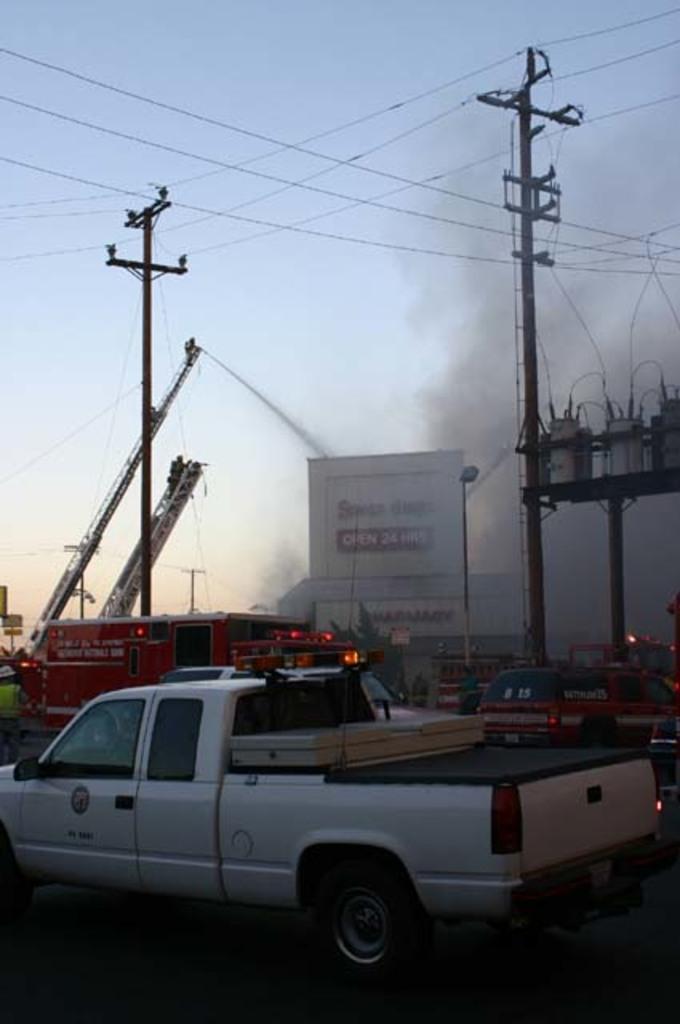Please provide a concise description of this image. In this image there are cars and a fire truck, in front of the fire truck there is a billboard, electric poles with cables on it and transformers with cables, behind the billboard there are buildings and sign boards. 